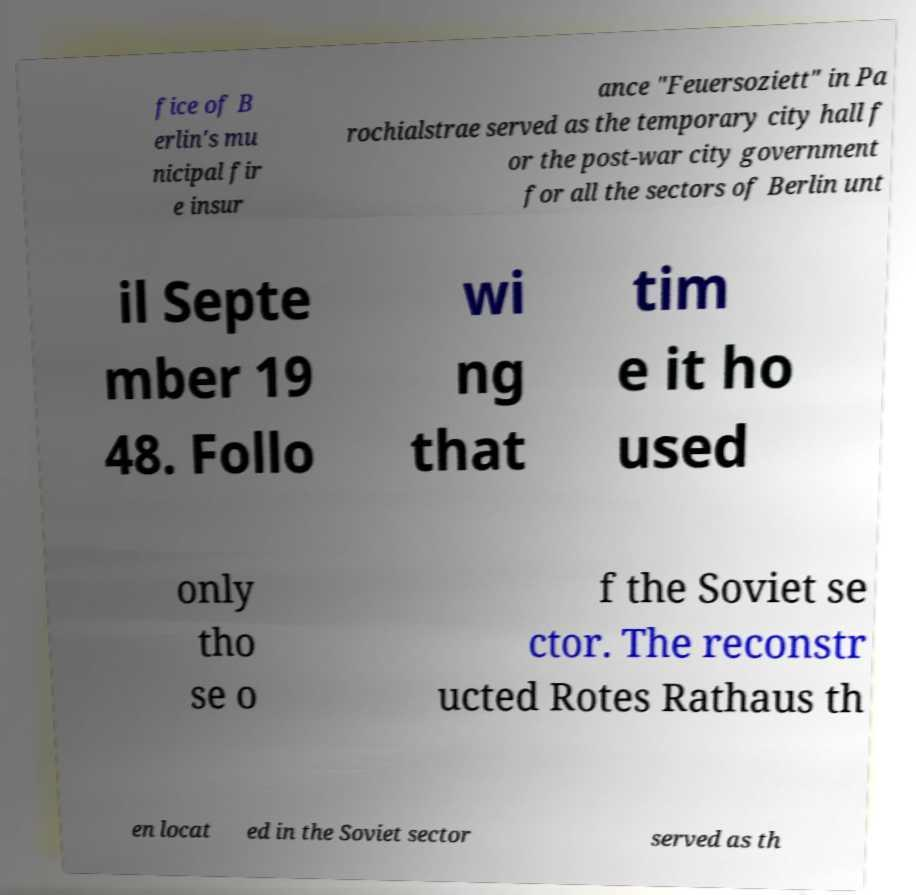There's text embedded in this image that I need extracted. Can you transcribe it verbatim? fice of B erlin's mu nicipal fir e insur ance "Feuersoziett" in Pa rochialstrae served as the temporary city hall f or the post-war city government for all the sectors of Berlin unt il Septe mber 19 48. Follo wi ng that tim e it ho used only tho se o f the Soviet se ctor. The reconstr ucted Rotes Rathaus th en locat ed in the Soviet sector served as th 